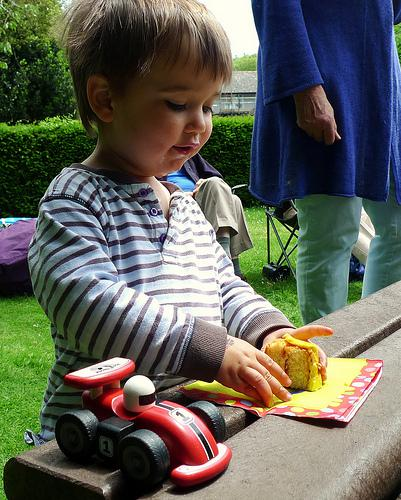Question: where is the cake?
Choices:
A. On a plate.
B. On a napkin.
C. In a box.
D. On the table.
Answer with the letter. Answer: B Question: what kind of toy is there?
Choices:
A. Train.
B. Airplane.
C. Car.
D. Tractor.
Answer with the letter. Answer: C Question: who is wearing a striped shirt?
Choices:
A. The man.
B. The child.
C. The baby.
D. The women.
Answer with the letter. Answer: B 